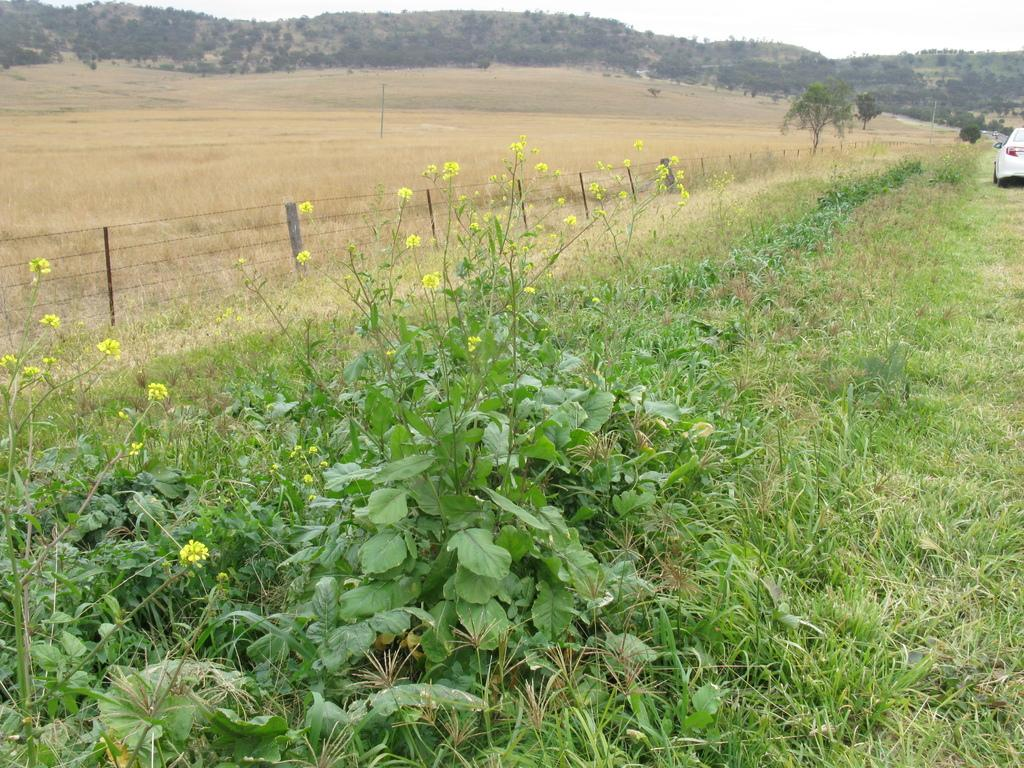What type of vegetation can be seen in the image? There are flower plants and grass visible in the image. What type of structure is present in the image? There is a fence in the image. What other natural elements can be seen in the image? There are trees in the image. What is on the right side of the image? There is a car on the right side of the image. What can be seen in the background of the image? There are hills and the sky visible in the background of the image. How many days of the week are visible in the image? There are no days of the week visible in the image; it is a still image of a landscape. Can you tell me which route the car is taking in the image? There is no indication of a specific route in the image; the car is simply parked on the right side. 